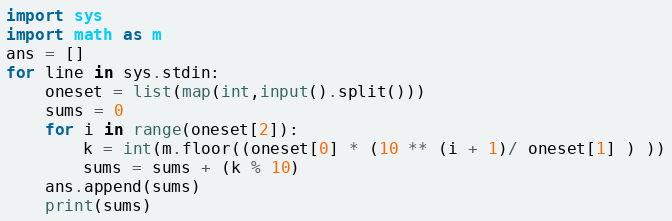Convert code to text. <code><loc_0><loc_0><loc_500><loc_500><_Python_>import sys
import math as m
ans = []
for line in sys.stdin: 
    oneset = list(map(int,input().split()))
    sums = 0
    for i in range(oneset[2]):
        k = int(m.floor((oneset[0] * (10 ** (i + 1)/ oneset[1] ) ))
        sums = sums + (k % 10)
    ans.append(sums)
    print(sums)
</code> 